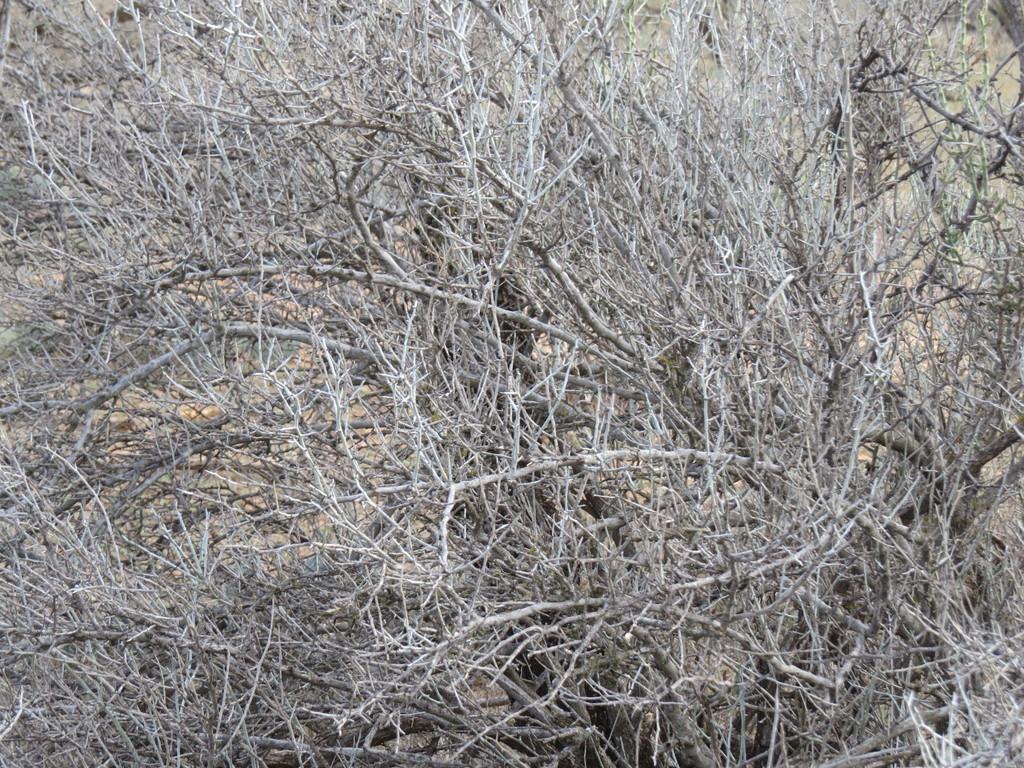In one or two sentences, can you explain what this image depicts? In this picture I can see there are branches of the trees and there are few twigs and there is soil on the floor. 